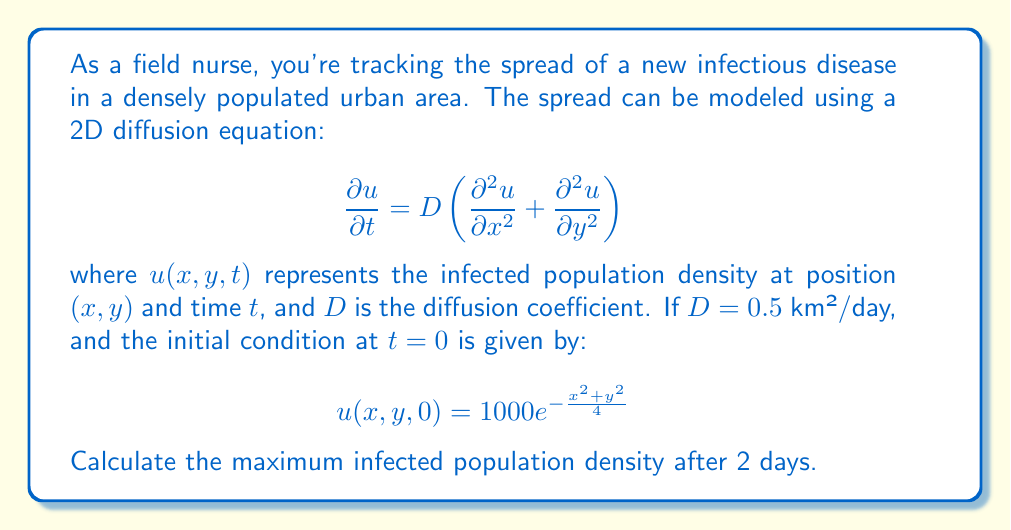Can you solve this math problem? To solve this problem, we'll follow these steps:

1) The solution to the 2D diffusion equation with an initial Gaussian distribution is:

   $$u(x,y,t) = \frac{M}{4\pi Dt + \sigma^2} e^{-\frac{x^2+y^2}{4Dt + \sigma^2}}$$

   where $M$ is the total initial population and $\sigma^2$ is the initial variance.

2) From the initial condition, we can see that $\sigma^2 = 4$ and $M = 1000 \cdot 4\pi = 4000\pi$.

3) Substituting these values and $D = 0.5$, $t = 2$ into the solution:

   $$u(x,y,2) = \frac{4000\pi}{4\pi(0.5 \cdot 2) + 4} e^{-\frac{x^2+y^2}{4(0.5 \cdot 2) + 4}}$$

4) Simplify:
   
   $$u(x,y,2) = \frac{4000\pi}{4\pi + 4} e^{-\frac{x^2+y^2}{8}}$$

5) The maximum density will occur at the center, where $x = y = 0$:

   $$u_{max} = u(0,0,2) = \frac{4000\pi}{4\pi + 4} \approx 310.95$$

6) Round to the nearest whole number as we're dealing with a population.
Answer: 311 infected individuals per km² 